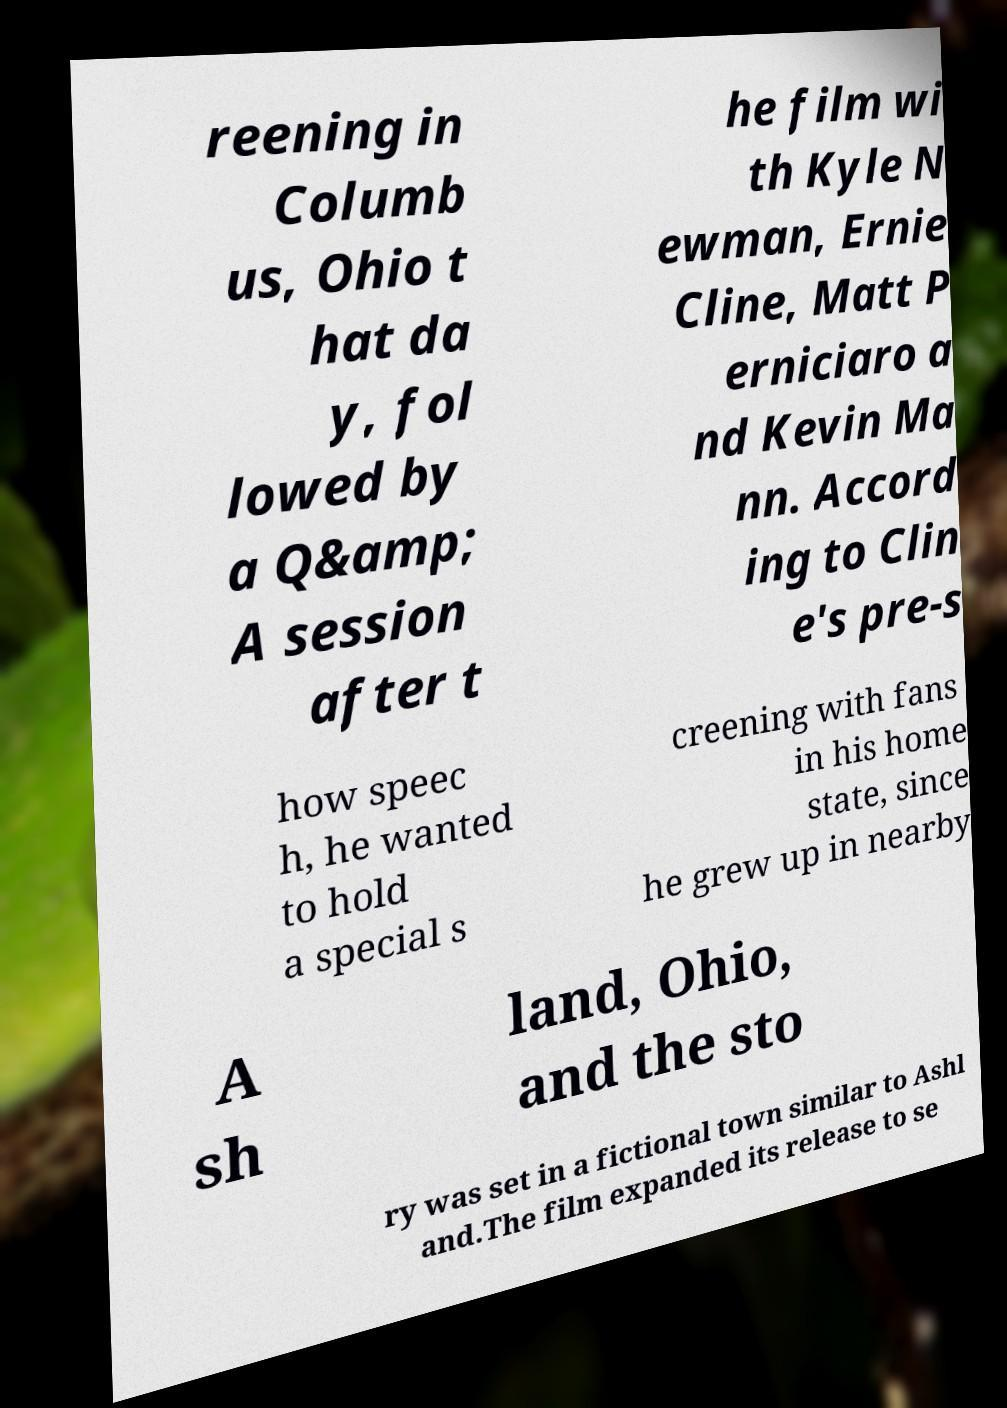Could you assist in decoding the text presented in this image and type it out clearly? reening in Columb us, Ohio t hat da y, fol lowed by a Q&amp; A session after t he film wi th Kyle N ewman, Ernie Cline, Matt P erniciaro a nd Kevin Ma nn. Accord ing to Clin e's pre-s how speec h, he wanted to hold a special s creening with fans in his home state, since he grew up in nearby A sh land, Ohio, and the sto ry was set in a fictional town similar to Ashl and.The film expanded its release to se 